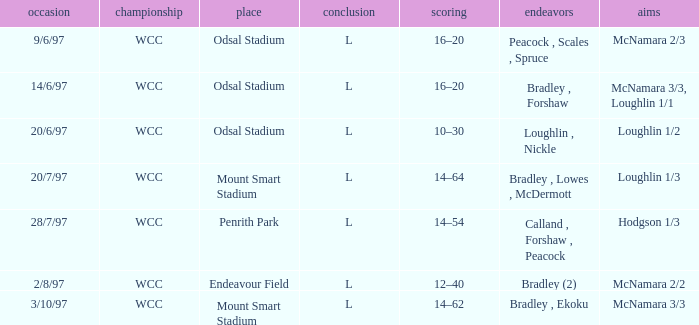On 20/6/97, what was the final score? 10–30. 